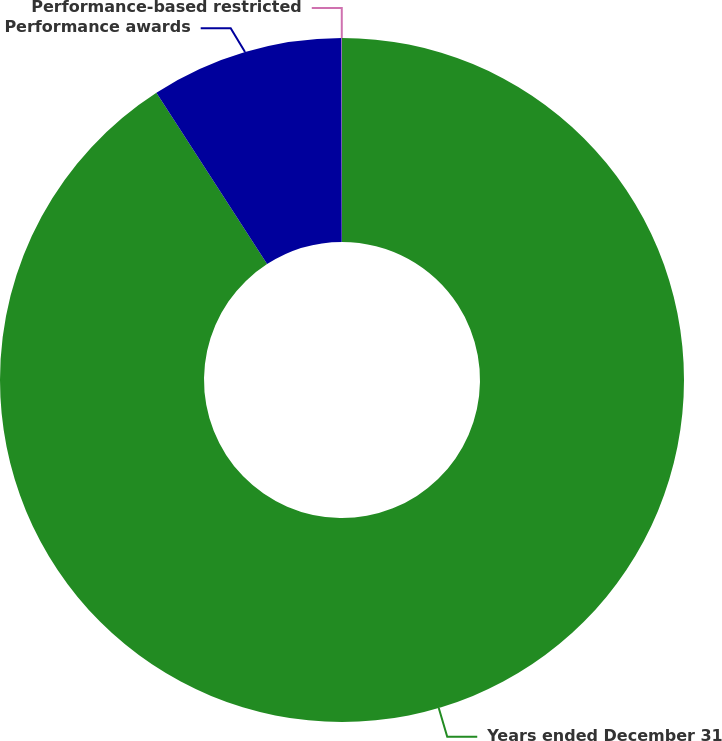Convert chart to OTSL. <chart><loc_0><loc_0><loc_500><loc_500><pie_chart><fcel>Years ended December 31<fcel>Performance awards<fcel>Performance-based restricted<nl><fcel>90.87%<fcel>9.11%<fcel>0.02%<nl></chart> 